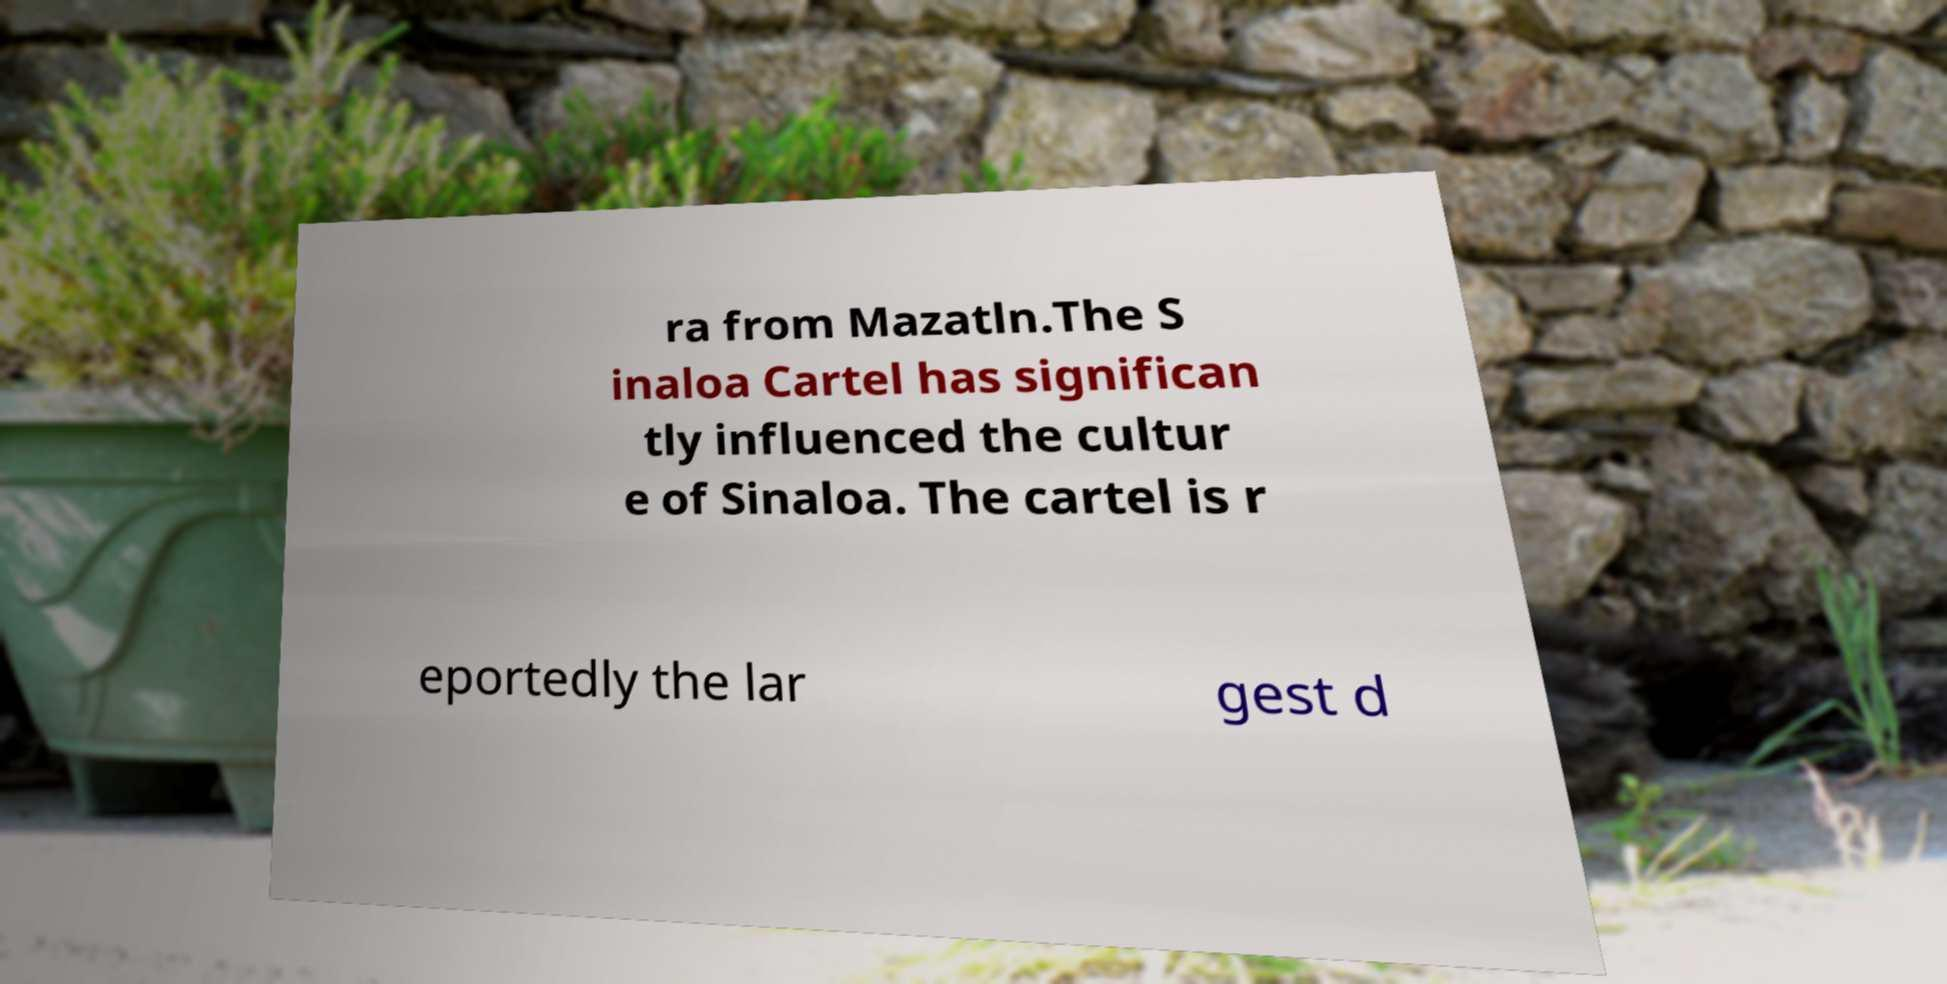Can you read and provide the text displayed in the image?This photo seems to have some interesting text. Can you extract and type it out for me? ra from Mazatln.The S inaloa Cartel has significan tly influenced the cultur e of Sinaloa. The cartel is r eportedly the lar gest d 